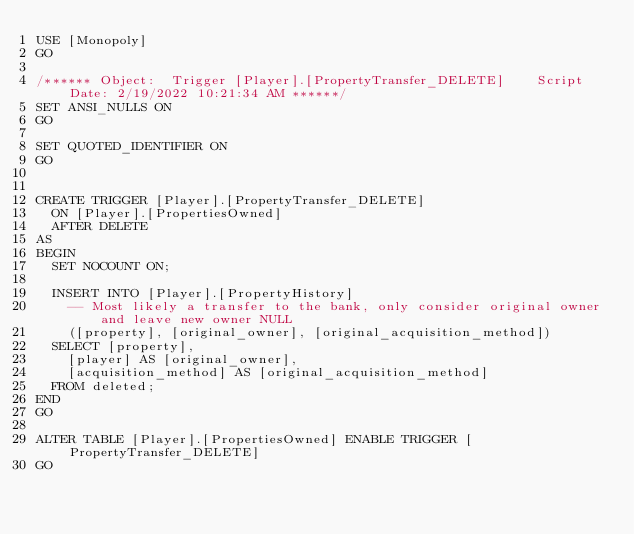<code> <loc_0><loc_0><loc_500><loc_500><_SQL_>USE [Monopoly]
GO

/****** Object:  Trigger [Player].[PropertyTransfer_DELETE]    Script Date: 2/19/2022 10:21:34 AM ******/
SET ANSI_NULLS ON
GO

SET QUOTED_IDENTIFIER ON
GO


CREATE TRIGGER [Player].[PropertyTransfer_DELETE]
	ON [Player].[PropertiesOwned]
	AFTER DELETE
AS
BEGIN
	SET NOCOUNT ON;

	INSERT INTO [Player].[PropertyHistory]
		-- Most likely a transfer to the bank, only consider original owner and leave new owner NULL
		([property], [original_owner], [original_acquisition_method])
	SELECT [property],
		[player] AS [original_owner],
		[acquisition_method] AS [original_acquisition_method]
	FROM deleted;
END
GO

ALTER TABLE [Player].[PropertiesOwned] ENABLE TRIGGER [PropertyTransfer_DELETE]
GO


</code> 